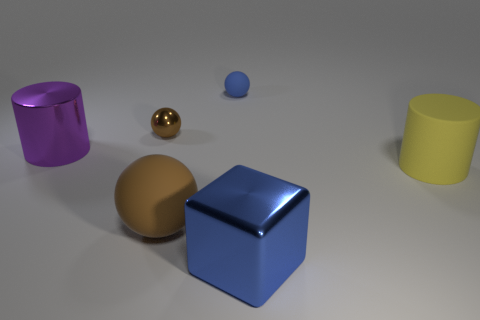Subtract all rubber balls. How many balls are left? 1 Add 2 tiny cyan metal spheres. How many objects exist? 8 Subtract all cubes. How many objects are left? 5 Subtract all shiny cylinders. Subtract all yellow cylinders. How many objects are left? 4 Add 3 big cylinders. How many big cylinders are left? 5 Add 1 big yellow spheres. How many big yellow spheres exist? 1 Subtract 0 brown cylinders. How many objects are left? 6 